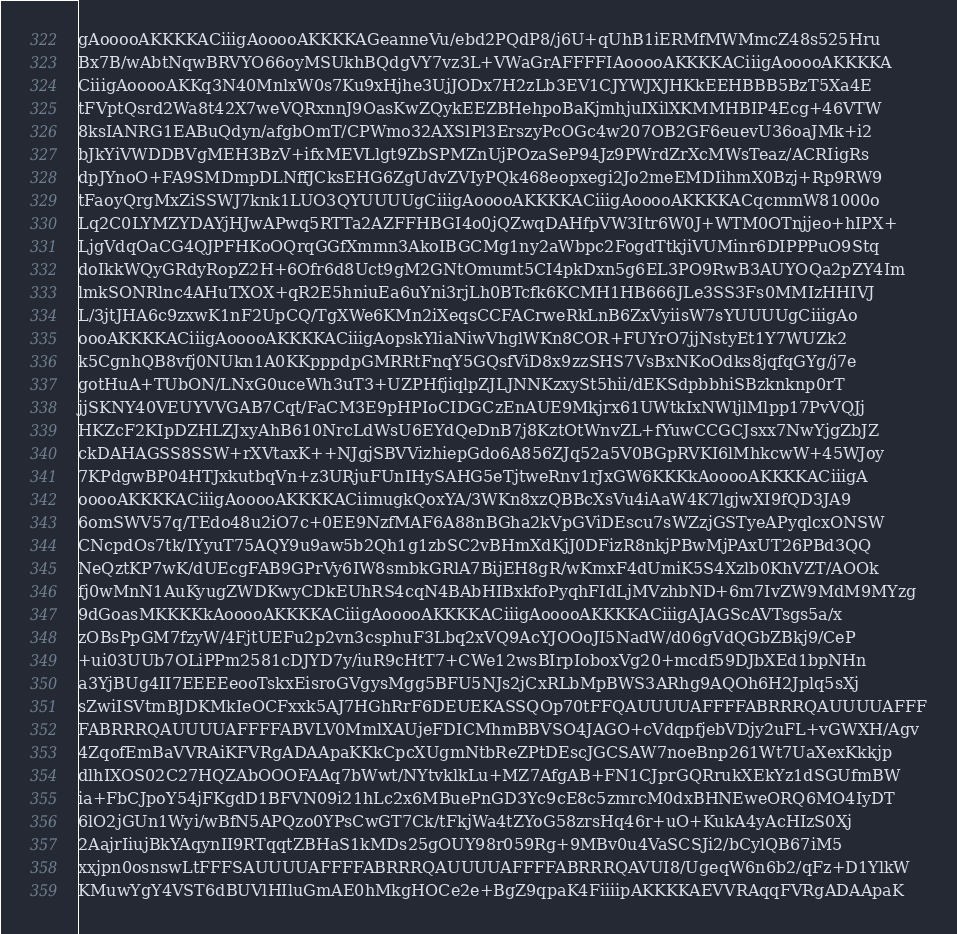<code> <loc_0><loc_0><loc_500><loc_500><_XML_>gAooooAKKKKACiiigAooooAKKKKAGeanneVu/ebd2PQdP8/j6U+qUhB1iERMfMWMmcZ48s525Hru
Bx7B/wAbtNqwBRVYO66oyMSUkhBQdgVY7vz3L+VWaGrAFFFFIAooooAKKKKACiiigAooooAKKKKA
CiiigAooooAKKq3N40MnlxW0s7Ku9xHjhe3UjJODx7H2zLb3EV1CJYWJXJHKkEEHBBB5BzT5Xa4E
tFVptQsrd2Wa8t42X7weVQRxnnJ9OasKwZQykEEZBHehpoBaKjmhjuIXilXKMMHBIP4Ecg+46VTW
8ksIANRG1EABuQdyn/afgbOmT/CPWmo32AXSlPl3ErszyPcOGc4w207OB2GF6euevU36oaJMk+i2
bJkYiVWDDBVgMEH3BzV+ifxMEVLlgt9ZbSPMZnUjPOzaSeP94Jz9PWrdZrXcMWsTeaz/ACRIigRs
dpJYnoO+FA9SMDmpDLNffJCksEHG6ZgUdvZVIyPQk468eopxegi2Jo2meEMDIihmX0Bzj+Rp9RW9
tFaoyQrgMxZiSSWJ7knk1LUO3QYUUUUgCiiigAooooAKKKKACiiigAooooAKKKKACqcmmW81000o
Lq2C0LYMZYDAYjHJwAPwq5RTTa2AZFFHBGI4o0jQZwqDAHfpVW3Itr6W0J+WTM0OTnjjeo+hIPX+
LjgVdqOaCG4QJPFHKoOQrqGGfXmmn3AkoIBGCMg1ny2aWbpc2FogdTtkjiVUMinr6DIPPPuO9Stq
doIkkWQyGRdyRopZ2H+6Ofr6d8Uct9gM2GNtOmumt5CI4pkDxn5g6EL3PO9RwB3AUYOQa2pZY4Im
lmkSONRlnc4AHuTXOX+qR2E5hniuEa6uYni3rjLh0BTcfk6KCMH1HB666JLe3SS3Fs0MMIzHHIVJ
L/3jtJHA6c9zxwK1nF2UpCQ/TgXWe6KMn2iXeqsCCFACrweRkLnB6ZxVyiisW7sYUUUUgCiiigAo
oooAKKKKACiiigAooooAKKKKACiiigAopskYliaNiwVhglWKn8COR+FUYrO7jjNstyEt1Y7WUZk2
k5CgnhQB8vfj0NUkn1A0KKpppdpGMRRtFnqY5GQsfViD8x9zzSHS7VsBxNKoOdks8jqfqGYg/j7e
gotHuA+TUbON/LNxG0uceWh3uT3+UZPHfjiqlpZJLJNNKzxySt5hii/dEKSdpbbhiSBzknknp0rT
jjSKNY40VEUYVVGAB7Cqt/FaCM3E9pHPIoCIDGCzEnAUE9Mkjrx61UWtkIxNWljlMlpp17PvVQJj
HKZcF2KIpDZHLZJxyAhB610NrcLdWsU6EYdQeDnB7j8KztOtWnvZL+fYuwCCGCJsxx7NwYjgZbJZ
ckDAHAGSS8SSW+rXVtaxK++NJgjSBVVizhiepGdo6A856ZJq52a5V0BGpRVKI6lMhkcwW+45WJoy
7KPdgwBP04HTJxkutbqVn+z3URjuFUnIHySAHG5eTjtweRnv1rJxGW6KKKkAooooAKKKKACiiigA
ooooAKKKKACiiigAooooAKKKKACiimugkQoxYA/3WKn8xzQBBcXsVu4iAaW4K7lgjwXI9fQD3JA9
6omSWV57q/TEdo48u2iO7c+0EE9NzfMAF6A88nBGha2kVpGViDEscu7sWZzjGSTyeAPyqlcxONSW
CNcpdOs7tk/IYyuT75AQY9u9aw5b2Qh1g1zbSC2vBHmXdKjJ0DFizR8nkjPBwMjPAxUT26PBd3QQ
NeQztKP7wK/dUEcgFAB9GPrVy6IW8smbkGRlA7BijEH8gR/wKmxF4dUmiK5S4Xzlb0KhVZT/AOOk
fj0wMnN1AuKyugZWDKwyCDkEUhRS4cqN4BAbHIBxkfoPyqhFIdLjMVzhbND+6m7IvZW9MdM9MYzg
9dGoasMKKKKkAooooAKKKKACiiigAooooAKKKKACiiigAooooAKKKKACiiigAJAGScAVTsgs5a/x
zOBsPpGM7fzyW/4FjtUEFu2p2vn3csphuF3Lbq2xVQ9AcYJOOoJI5NadW/d06gVdQGbZBkj9/CeP
+ui03UUb7OLiPPm2581cDJYD7y/iuR9cHtT7+CWe12wsBIrpIoboxVg20+mcdf59DJbXEd1bpNHn
a3YjBUg4II7EEEEeooTskxEisroGVgysMgg5BFU5NJs2jCxRLbMpBWS3ARhg9AQOh6H2Jplq5sXj
sZwiISVtmBJDKMkIeOCFxxk5AJ7HGhRrF6DEUEKASSQOp70tFFQAUUUUAFFFFABRRRQAUUUUAFFF
FABRRRQAUUUUAFFFFABVLV0MmlXAUjeFDICMhmBBVSO4JAGO+cVdqpfjebVDjy2uFL+vGWXH/Agv
4ZqofEmBaVVRAiKFVRgADAApaKKkCpcXUgmNtbReZPtDEscJGCSAW7noeBnp261Wt7UaXexKkkjp
dlhIXOS02C27HQZAbOOOFAAq7bWwt/NYtvklkLu+MZ7AfgAB+FN1CJprGQRrukXEkYz1dSGUfmBW
ia+FbCJpoY54jFKgdD1BFVN09i21hLc2x6MBuePnGD3Yc9cE8c5zmrcM0dxBHNEweORQ6MO4IyDT
6lO2jGUn1Wyi/wBfN5APQzo0YPsCwGT7Ck/tFkjWa4tZYoG58zrsHq46r+uO+KukA4yAcHIzS0Xj
2AajrIiujBkYAqynII9RTqqtZBHaS1kMDs25gOUY98r059Rg+9MBv0u4VaSCSJi2/bCylQB67iM5
xxjpn0osnswLtFFFSAUUUUAFFFFABRRRQAUUUUAFFFFABRRRQAVUI8/UgeqW6n6b2/qFz+D1YlkW
KMuwYgY4VST6dBUVlHIluGmAE0hMkgHOCe2e+BgZ9qpaK4FiiiipAKKKKAEVVRAqqFVRgADAApaK</code> 